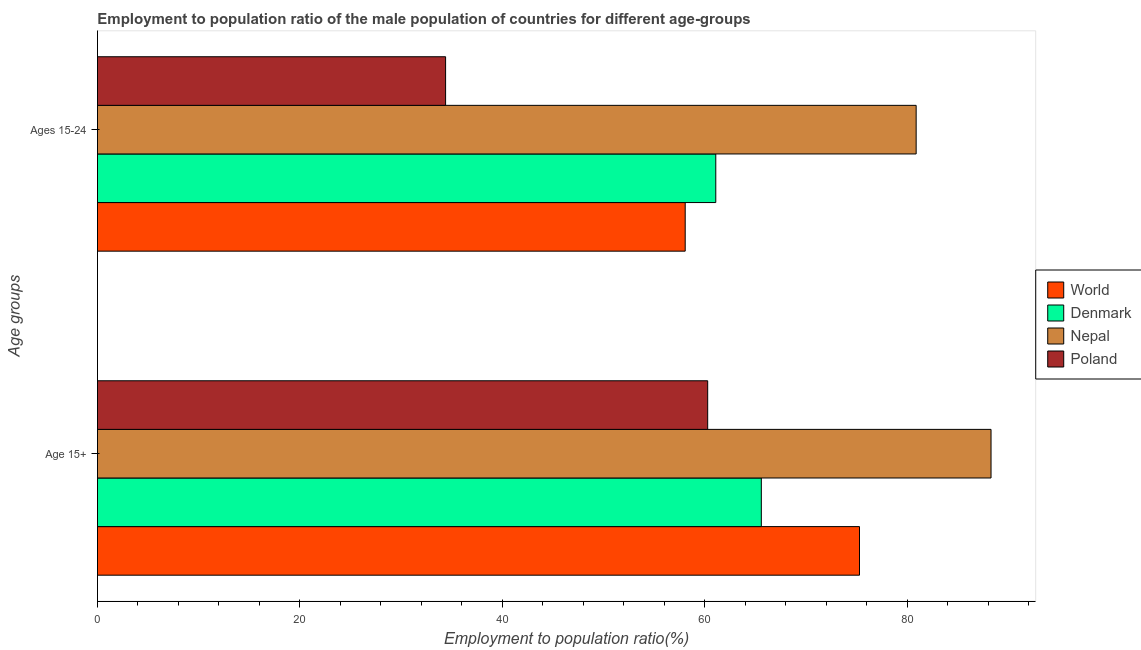Are the number of bars per tick equal to the number of legend labels?
Your answer should be compact. Yes. How many bars are there on the 1st tick from the top?
Offer a very short reply. 4. What is the label of the 2nd group of bars from the top?
Your answer should be compact. Age 15+. What is the employment to population ratio(age 15-24) in Poland?
Your response must be concise. 34.4. Across all countries, what is the maximum employment to population ratio(age 15+)?
Make the answer very short. 88.3. Across all countries, what is the minimum employment to population ratio(age 15+)?
Offer a terse response. 60.3. In which country was the employment to population ratio(age 15+) maximum?
Your answer should be very brief. Nepal. In which country was the employment to population ratio(age 15-24) minimum?
Make the answer very short. Poland. What is the total employment to population ratio(age 15-24) in the graph?
Ensure brevity in your answer.  234.48. What is the difference between the employment to population ratio(age 15+) in World and that in Denmark?
Your response must be concise. 9.7. What is the difference between the employment to population ratio(age 15-24) in Denmark and the employment to population ratio(age 15+) in World?
Give a very brief answer. -14.2. What is the average employment to population ratio(age 15+) per country?
Offer a terse response. 72.38. What is the difference between the employment to population ratio(age 15-24) and employment to population ratio(age 15+) in Denmark?
Give a very brief answer. -4.5. What is the ratio of the employment to population ratio(age 15+) in Nepal to that in Poland?
Give a very brief answer. 1.46. Is the employment to population ratio(age 15+) in Poland less than that in Denmark?
Offer a very short reply. Yes. What does the 2nd bar from the top in Age 15+ represents?
Provide a succinct answer. Nepal. What is the difference between two consecutive major ticks on the X-axis?
Keep it short and to the point. 20. Does the graph contain any zero values?
Your response must be concise. No. What is the title of the graph?
Your answer should be very brief. Employment to population ratio of the male population of countries for different age-groups. Does "Bolivia" appear as one of the legend labels in the graph?
Provide a short and direct response. No. What is the label or title of the Y-axis?
Your answer should be very brief. Age groups. What is the Employment to population ratio(%) of World in Age 15+?
Your response must be concise. 75.3. What is the Employment to population ratio(%) of Denmark in Age 15+?
Give a very brief answer. 65.6. What is the Employment to population ratio(%) of Nepal in Age 15+?
Your answer should be compact. 88.3. What is the Employment to population ratio(%) of Poland in Age 15+?
Keep it short and to the point. 60.3. What is the Employment to population ratio(%) of World in Ages 15-24?
Your response must be concise. 58.08. What is the Employment to population ratio(%) of Denmark in Ages 15-24?
Give a very brief answer. 61.1. What is the Employment to population ratio(%) in Nepal in Ages 15-24?
Give a very brief answer. 80.9. What is the Employment to population ratio(%) of Poland in Ages 15-24?
Your response must be concise. 34.4. Across all Age groups, what is the maximum Employment to population ratio(%) in World?
Provide a succinct answer. 75.3. Across all Age groups, what is the maximum Employment to population ratio(%) of Denmark?
Provide a short and direct response. 65.6. Across all Age groups, what is the maximum Employment to population ratio(%) of Nepal?
Provide a succinct answer. 88.3. Across all Age groups, what is the maximum Employment to population ratio(%) in Poland?
Offer a terse response. 60.3. Across all Age groups, what is the minimum Employment to population ratio(%) of World?
Offer a very short reply. 58.08. Across all Age groups, what is the minimum Employment to population ratio(%) of Denmark?
Make the answer very short. 61.1. Across all Age groups, what is the minimum Employment to population ratio(%) in Nepal?
Offer a terse response. 80.9. Across all Age groups, what is the minimum Employment to population ratio(%) in Poland?
Make the answer very short. 34.4. What is the total Employment to population ratio(%) in World in the graph?
Provide a short and direct response. 133.38. What is the total Employment to population ratio(%) of Denmark in the graph?
Give a very brief answer. 126.7. What is the total Employment to population ratio(%) of Nepal in the graph?
Keep it short and to the point. 169.2. What is the total Employment to population ratio(%) in Poland in the graph?
Provide a short and direct response. 94.7. What is the difference between the Employment to population ratio(%) in World in Age 15+ and that in Ages 15-24?
Your response must be concise. 17.22. What is the difference between the Employment to population ratio(%) in Poland in Age 15+ and that in Ages 15-24?
Your answer should be very brief. 25.9. What is the difference between the Employment to population ratio(%) in World in Age 15+ and the Employment to population ratio(%) in Denmark in Ages 15-24?
Provide a short and direct response. 14.2. What is the difference between the Employment to population ratio(%) of World in Age 15+ and the Employment to population ratio(%) of Nepal in Ages 15-24?
Your answer should be very brief. -5.6. What is the difference between the Employment to population ratio(%) in World in Age 15+ and the Employment to population ratio(%) in Poland in Ages 15-24?
Ensure brevity in your answer.  40.9. What is the difference between the Employment to population ratio(%) of Denmark in Age 15+ and the Employment to population ratio(%) of Nepal in Ages 15-24?
Your answer should be very brief. -15.3. What is the difference between the Employment to population ratio(%) in Denmark in Age 15+ and the Employment to population ratio(%) in Poland in Ages 15-24?
Provide a succinct answer. 31.2. What is the difference between the Employment to population ratio(%) of Nepal in Age 15+ and the Employment to population ratio(%) of Poland in Ages 15-24?
Offer a terse response. 53.9. What is the average Employment to population ratio(%) in World per Age groups?
Provide a short and direct response. 66.69. What is the average Employment to population ratio(%) of Denmark per Age groups?
Your response must be concise. 63.35. What is the average Employment to population ratio(%) in Nepal per Age groups?
Make the answer very short. 84.6. What is the average Employment to population ratio(%) of Poland per Age groups?
Your answer should be compact. 47.35. What is the difference between the Employment to population ratio(%) in World and Employment to population ratio(%) in Denmark in Age 15+?
Your answer should be compact. 9.7. What is the difference between the Employment to population ratio(%) in World and Employment to population ratio(%) in Nepal in Age 15+?
Offer a terse response. -13. What is the difference between the Employment to population ratio(%) in World and Employment to population ratio(%) in Poland in Age 15+?
Give a very brief answer. 15. What is the difference between the Employment to population ratio(%) of Denmark and Employment to population ratio(%) of Nepal in Age 15+?
Give a very brief answer. -22.7. What is the difference between the Employment to population ratio(%) in Denmark and Employment to population ratio(%) in Poland in Age 15+?
Provide a succinct answer. 5.3. What is the difference between the Employment to population ratio(%) of World and Employment to population ratio(%) of Denmark in Ages 15-24?
Offer a terse response. -3.02. What is the difference between the Employment to population ratio(%) in World and Employment to population ratio(%) in Nepal in Ages 15-24?
Your response must be concise. -22.82. What is the difference between the Employment to population ratio(%) in World and Employment to population ratio(%) in Poland in Ages 15-24?
Your response must be concise. 23.68. What is the difference between the Employment to population ratio(%) of Denmark and Employment to population ratio(%) of Nepal in Ages 15-24?
Offer a terse response. -19.8. What is the difference between the Employment to population ratio(%) of Denmark and Employment to population ratio(%) of Poland in Ages 15-24?
Your answer should be very brief. 26.7. What is the difference between the Employment to population ratio(%) of Nepal and Employment to population ratio(%) of Poland in Ages 15-24?
Keep it short and to the point. 46.5. What is the ratio of the Employment to population ratio(%) in World in Age 15+ to that in Ages 15-24?
Your response must be concise. 1.3. What is the ratio of the Employment to population ratio(%) of Denmark in Age 15+ to that in Ages 15-24?
Your answer should be compact. 1.07. What is the ratio of the Employment to population ratio(%) of Nepal in Age 15+ to that in Ages 15-24?
Provide a short and direct response. 1.09. What is the ratio of the Employment to population ratio(%) of Poland in Age 15+ to that in Ages 15-24?
Provide a succinct answer. 1.75. What is the difference between the highest and the second highest Employment to population ratio(%) in World?
Your answer should be compact. 17.22. What is the difference between the highest and the second highest Employment to population ratio(%) in Poland?
Give a very brief answer. 25.9. What is the difference between the highest and the lowest Employment to population ratio(%) of World?
Your answer should be compact. 17.22. What is the difference between the highest and the lowest Employment to population ratio(%) in Poland?
Your answer should be very brief. 25.9. 